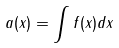<formula> <loc_0><loc_0><loc_500><loc_500>a ( x ) = \int f ( x ) d x</formula> 